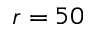<formula> <loc_0><loc_0><loc_500><loc_500>r = 5 0</formula> 